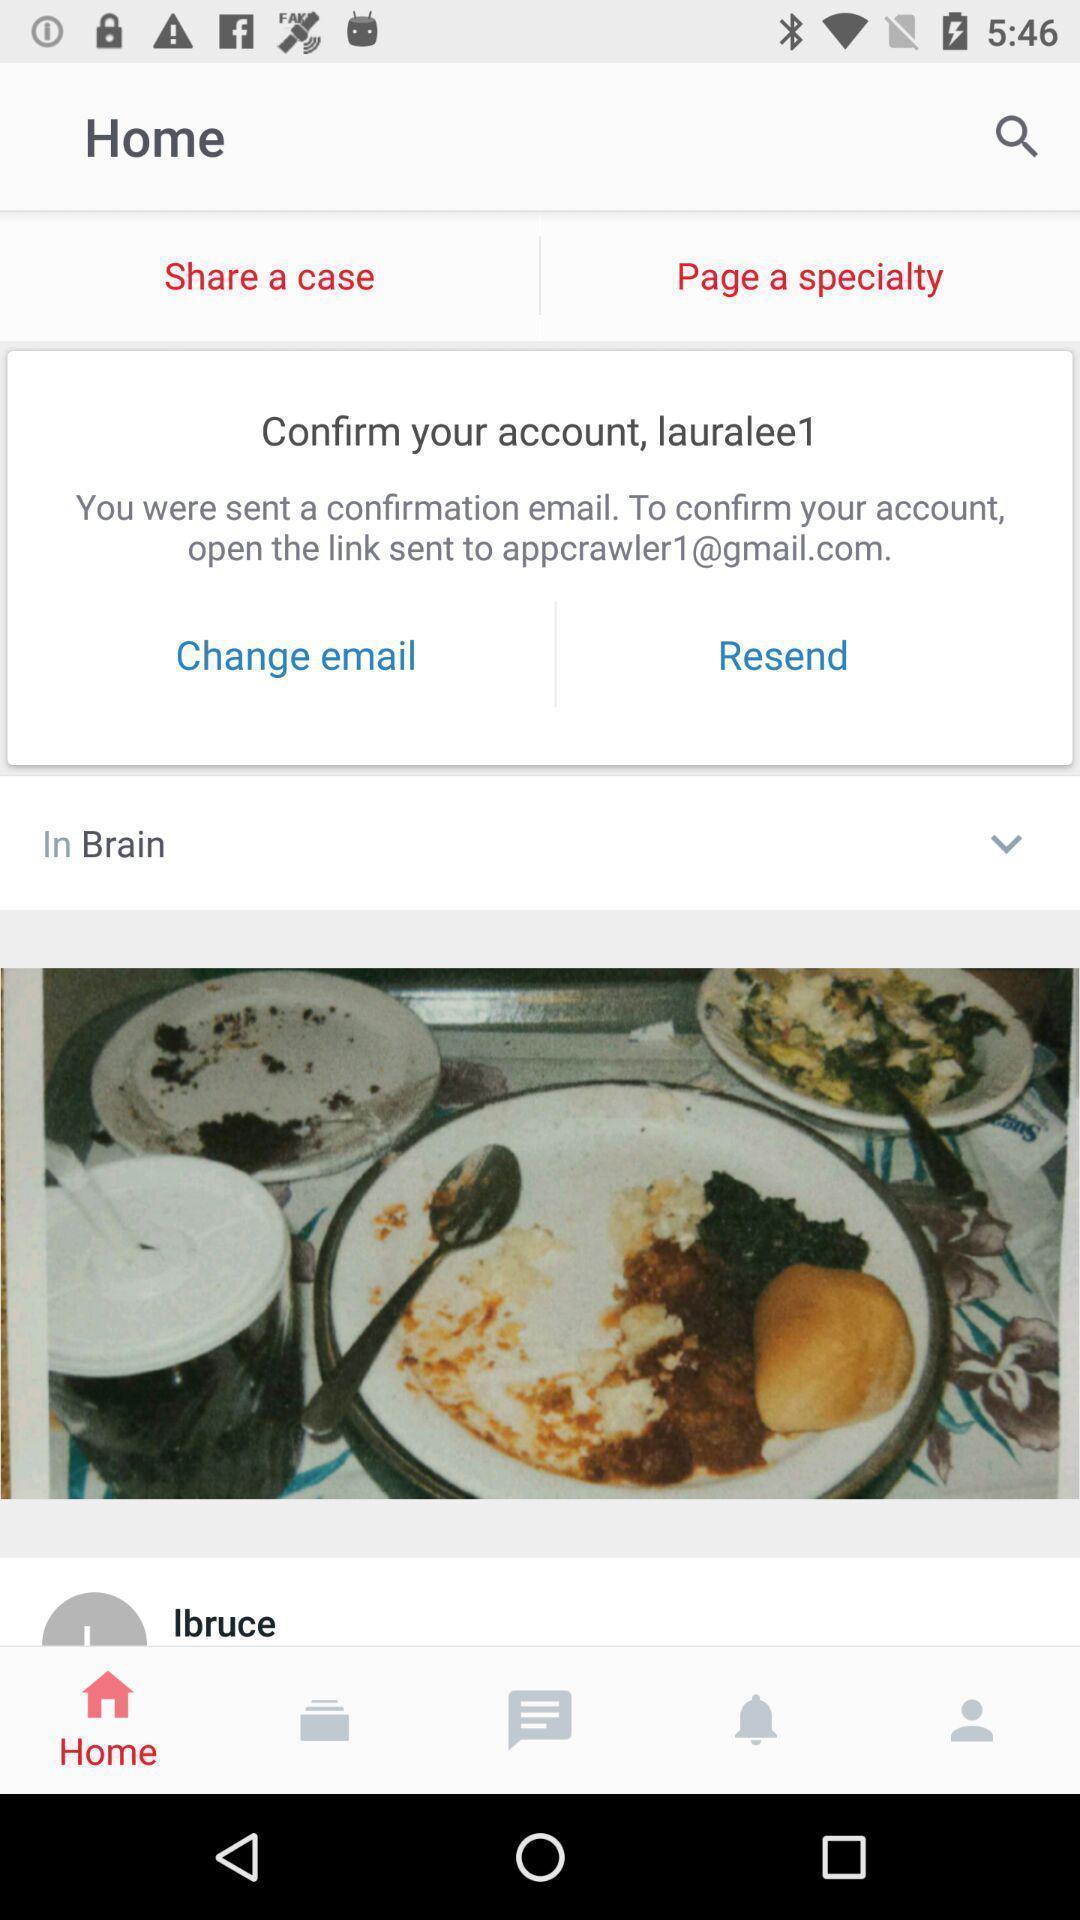What details can you identify in this image? Page showing the prompt on email. 